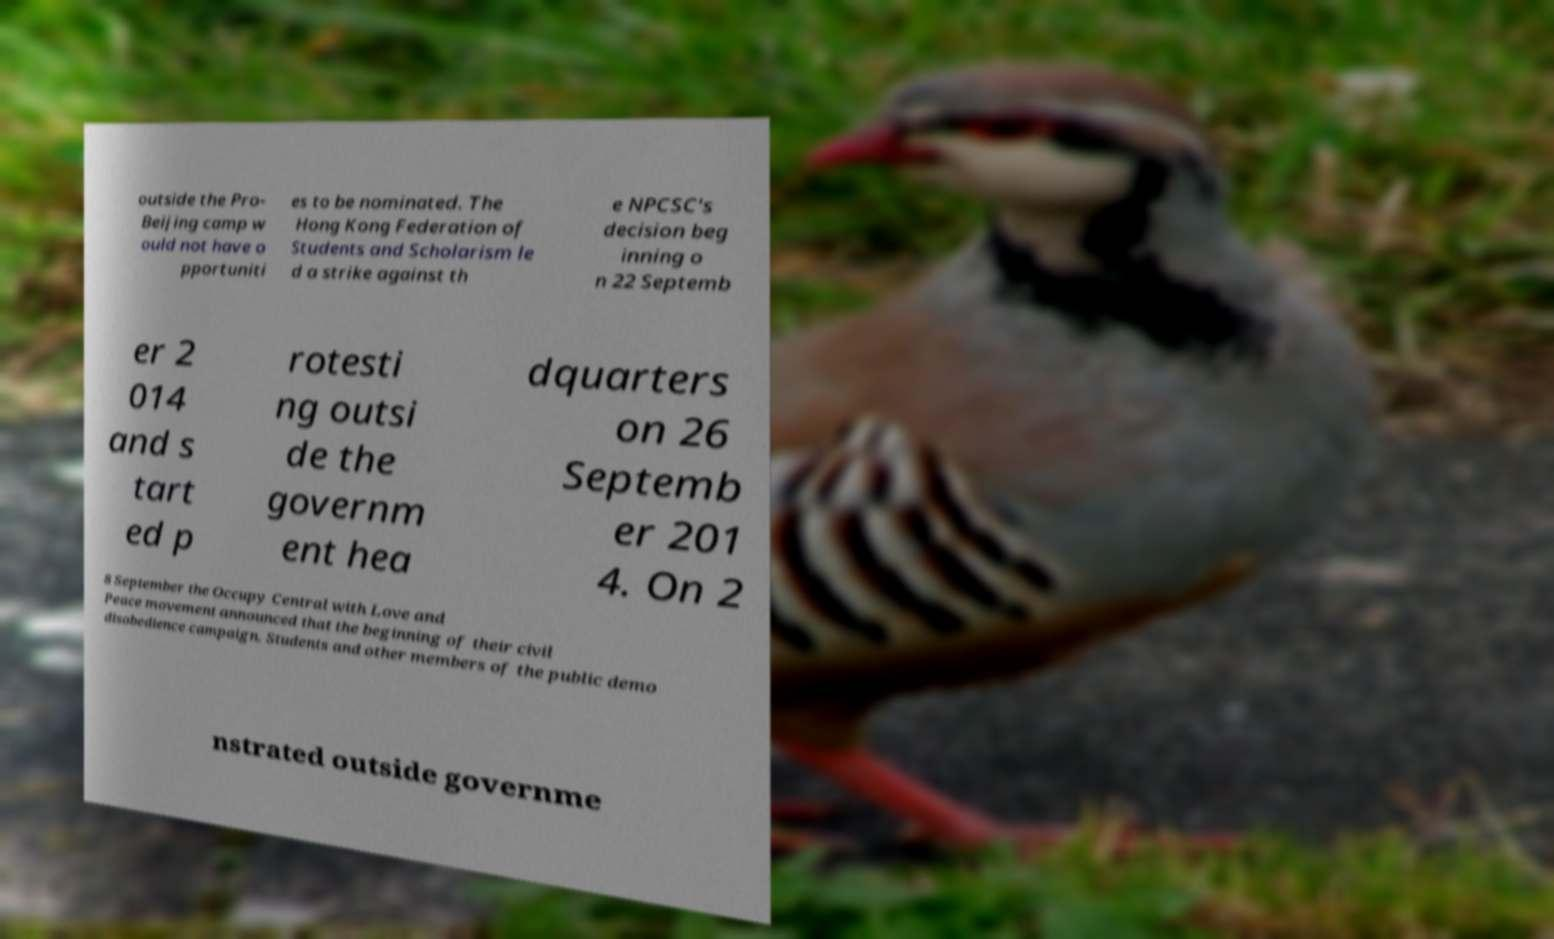Can you read and provide the text displayed in the image?This photo seems to have some interesting text. Can you extract and type it out for me? outside the Pro- Beijing camp w ould not have o pportuniti es to be nominated. The Hong Kong Federation of Students and Scholarism le d a strike against th e NPCSC's decision beg inning o n 22 Septemb er 2 014 and s tart ed p rotesti ng outsi de the governm ent hea dquarters on 26 Septemb er 201 4. On 2 8 September the Occupy Central with Love and Peace movement announced that the beginning of their civil disobedience campaign. Students and other members of the public demo nstrated outside governme 